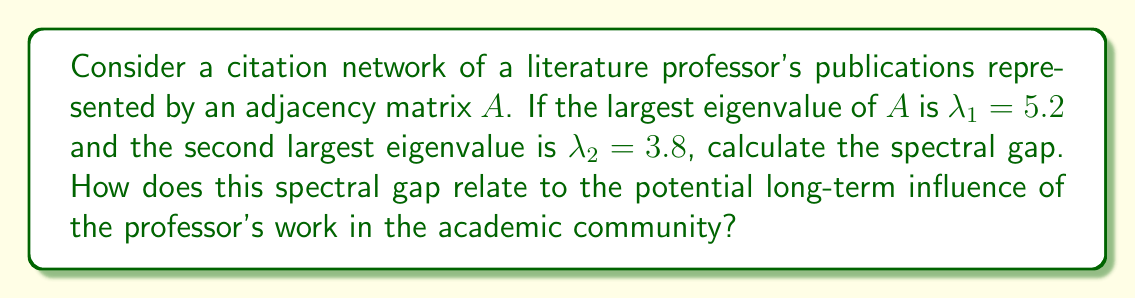Teach me how to tackle this problem. To solve this problem, we'll follow these steps:

1. Define the spectral gap:
   The spectral gap is the difference between the two largest eigenvalues of the adjacency matrix.

2. Calculate the spectral gap:
   Spectral gap = $\lambda_1 - \lambda_2$
   $$ \text{Spectral gap} = 5.2 - 3.8 = 1.4 $$

3. Interpret the spectral gap:
   In citation networks, a larger spectral gap indicates:
   a) Faster convergence of random walks on the network
   b) Better connectivity and information flow
   c) More robust network structure

4. Relate to the professor's influence:
   A larger spectral gap (1.4 in this case) suggests:
   a) The professor's work forms a well-connected body of literature
   b) Ideas spread more efficiently through the citation network
   c) The professor's publications have a cohesive impact on the field

5. Long-term influence prediction:
   The spectral gap of 1.4 indicates a moderate to strong potential for long-term influence. The professor's work is likely to:
   a) Maintain relevance over time
   b) Continue to be cited and referenced
   c) Shape future research directions in the field

In conclusion, the spectral gap of 1.4 suggests that the literature professor's work has a significant potential for long-term influence in the academic community, with a well-connected and impactful body of publications.
Answer: Spectral gap: 1.4; Indicates moderate to strong potential for long-term academic influence. 